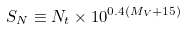Convert formula to latex. <formula><loc_0><loc_0><loc_500><loc_500>S _ { N } \equiv N _ { t } \times 1 0 ^ { 0 . 4 ( M _ { V } + 1 5 ) }</formula> 